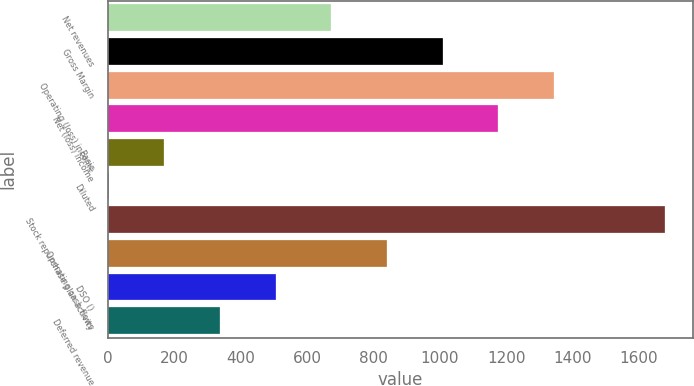<chart> <loc_0><loc_0><loc_500><loc_500><bar_chart><fcel>Net revenues<fcel>Gross Margin<fcel>Operating (loss) income<fcel>Net (loss) income<fcel>Basic<fcel>Diluted<fcel>Stock repurchase plan activity<fcel>Operating cash flows<fcel>DSO ()<fcel>Deferred revenue<nl><fcel>672.71<fcel>1008.27<fcel>1343.83<fcel>1176.05<fcel>169.37<fcel>1.59<fcel>1679.4<fcel>840.49<fcel>504.93<fcel>337.15<nl></chart> 